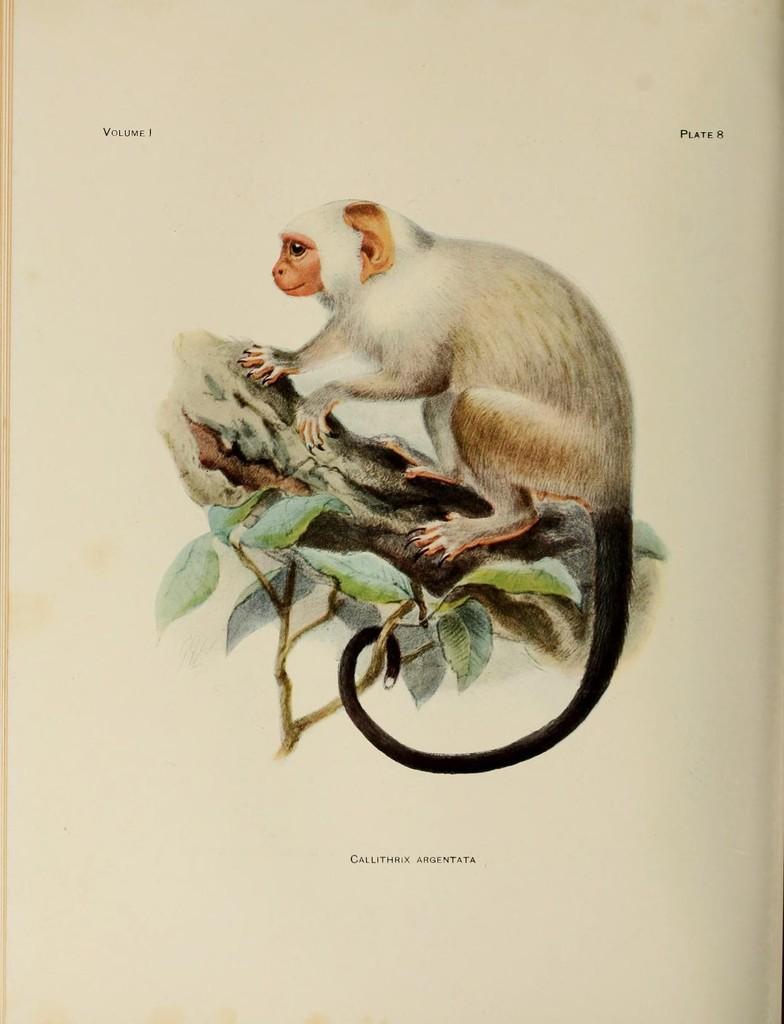Describe this image in one or two sentences. In the image there is a painting of a monkey standing on a tree. 